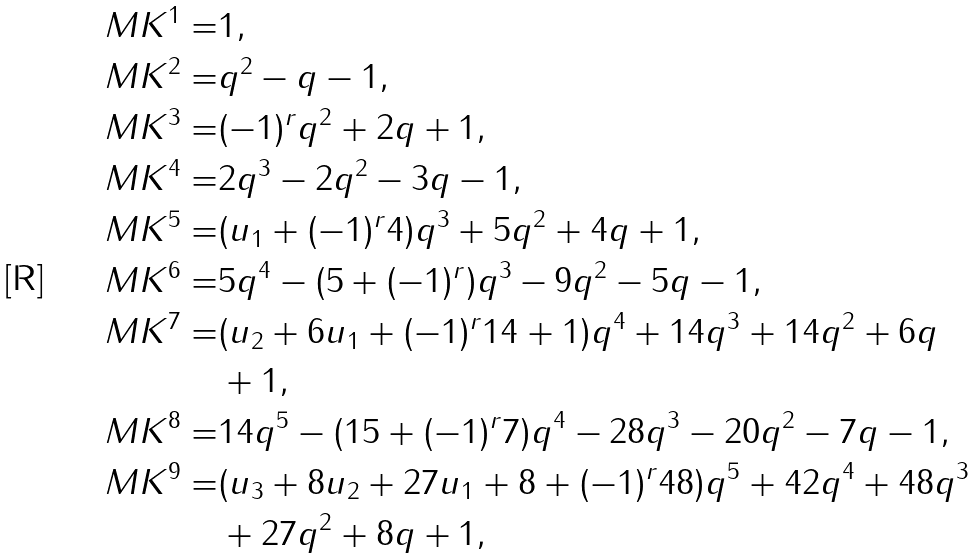Convert formula to latex. <formula><loc_0><loc_0><loc_500><loc_500>M K ^ { 1 } = & 1 , \\ M K ^ { 2 } = & q ^ { 2 } - q - 1 , \\ M K ^ { 3 } = & ( - 1 ) ^ { r } q ^ { 2 } + 2 q + 1 , \\ M K ^ { 4 } = & 2 q ^ { 3 } - 2 q ^ { 2 } - 3 q - 1 , \\ M K ^ { 5 } = & ( u _ { 1 } + ( - 1 ) ^ { r } 4 ) q ^ { 3 } + 5 q ^ { 2 } + 4 q + 1 , \\ M K ^ { 6 } = & 5 q ^ { 4 } - ( 5 + ( - 1 ) ^ { r } ) q ^ { 3 } - 9 q ^ { 2 } - 5 q - 1 , \\ M K ^ { 7 } = & ( u _ { 2 } + 6 u _ { 1 } + ( - 1 ) ^ { r } 1 4 + 1 ) q ^ { 4 } + 1 4 q ^ { 3 } + 1 4 q ^ { 2 } + 6 q \\ & + 1 , \\ M K ^ { 8 } = & 1 4 q ^ { 5 } - ( 1 5 + ( - 1 ) ^ { r } 7 ) q ^ { 4 } - 2 8 q ^ { 3 } - 2 0 q ^ { 2 } - 7 q - 1 , \\ M K ^ { 9 } = & ( u _ { 3 } + 8 u _ { 2 } + 2 7 u _ { 1 } + 8 + ( - 1 ) ^ { r } 4 8 ) q ^ { 5 } + 4 2 q ^ { 4 } + 4 8 q ^ { 3 } \\ & + 2 7 q ^ { 2 } + 8 q + 1 , \\</formula> 